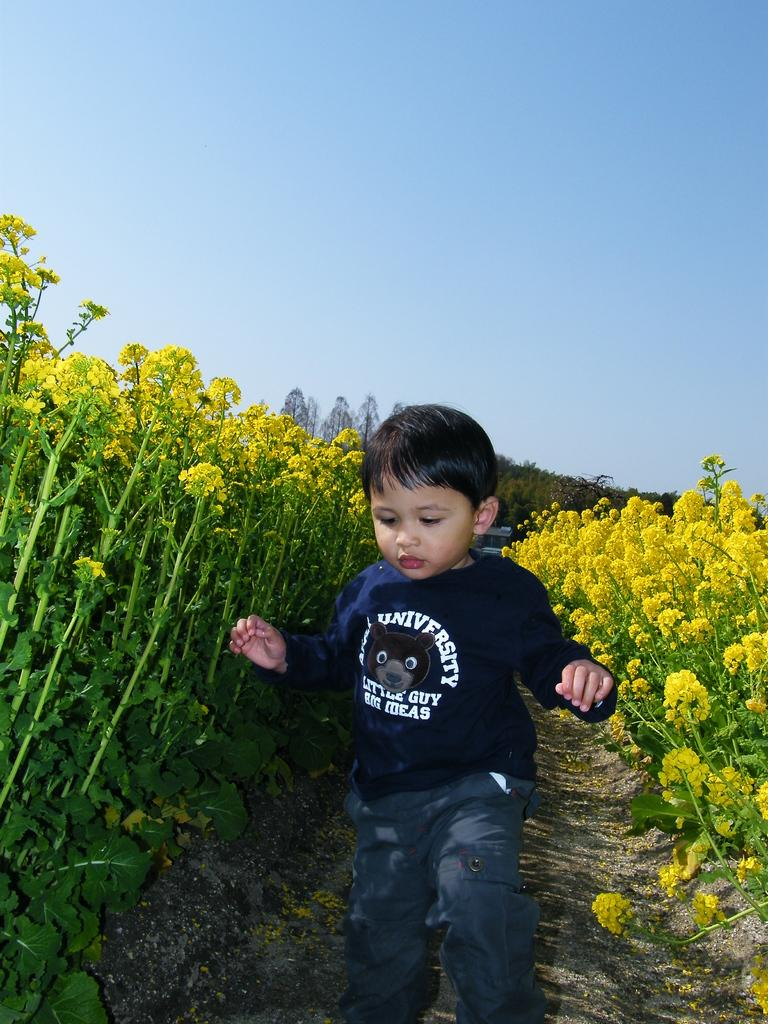What is the main subject of the image? The main subject of the image is a boy. What is the boy's position in the image? The boy is on the ground. What can be seen in the background of the image? There are flowers with plants in the background of the image. What type of boats can be seen in the image? There are no boats present in the image. Is the boy's aunt visible in the image? There is no mention of an aunt in the image, and therefore no such person can be observed. 